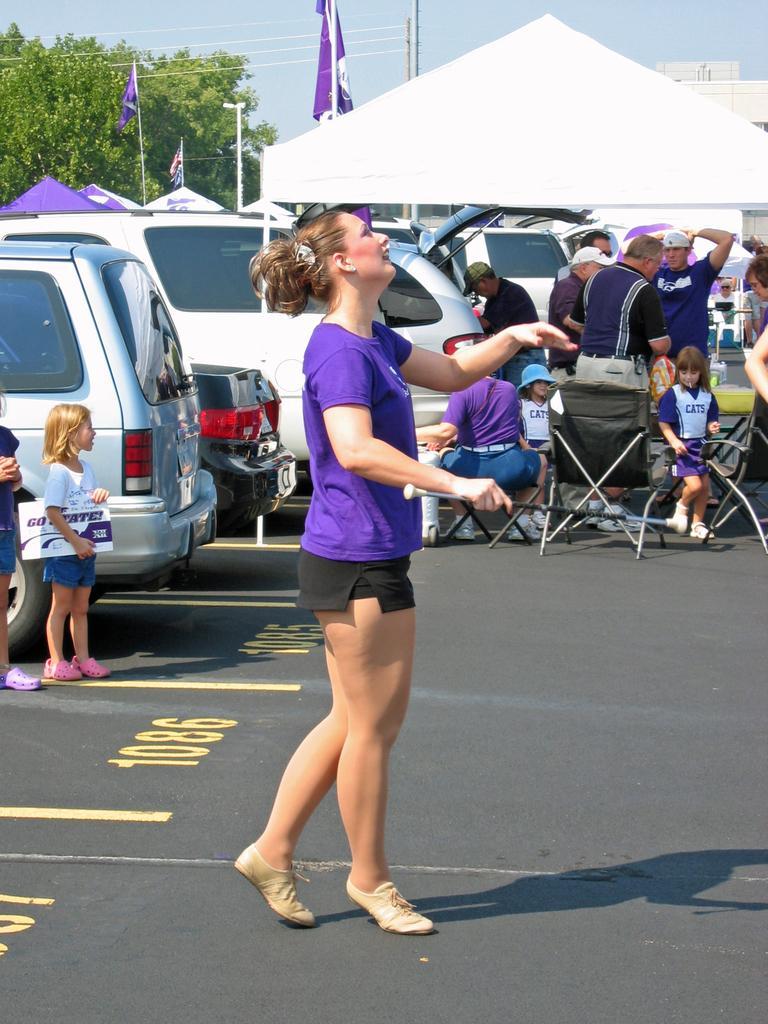Describe this image in one or two sentences. In this picture there is a woman who is standing on the road. On the left there is a girl who is standing near to the cars. On the right I can see some people who are sitting on the chair and some people are standing near to the table and tent. In the background I can see the street lights, poles, building and trees. At the top I can see the sky. 